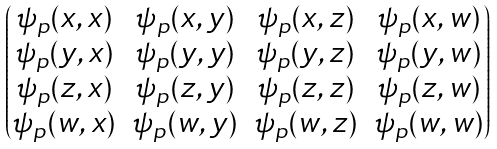<formula> <loc_0><loc_0><loc_500><loc_500>\begin{pmatrix} \psi _ { p } ( x , x ) & \psi _ { p } ( x , y ) & \psi _ { p } ( x , z ) & \psi _ { p } ( x , w ) \\ \psi _ { p } ( y , x ) & \psi _ { p } ( y , y ) & \psi _ { p } ( y , z ) & \psi _ { p } ( y , w ) \\ \psi _ { p } ( z , x ) & \psi _ { p } ( z , y ) & \psi _ { p } ( z , z ) & \psi _ { p } ( z , w ) \\ \psi _ { p } ( w , x ) & \psi _ { p } ( w , y ) & \psi _ { p } ( w , z ) & \psi _ { p } ( w , w ) \end{pmatrix}</formula> 